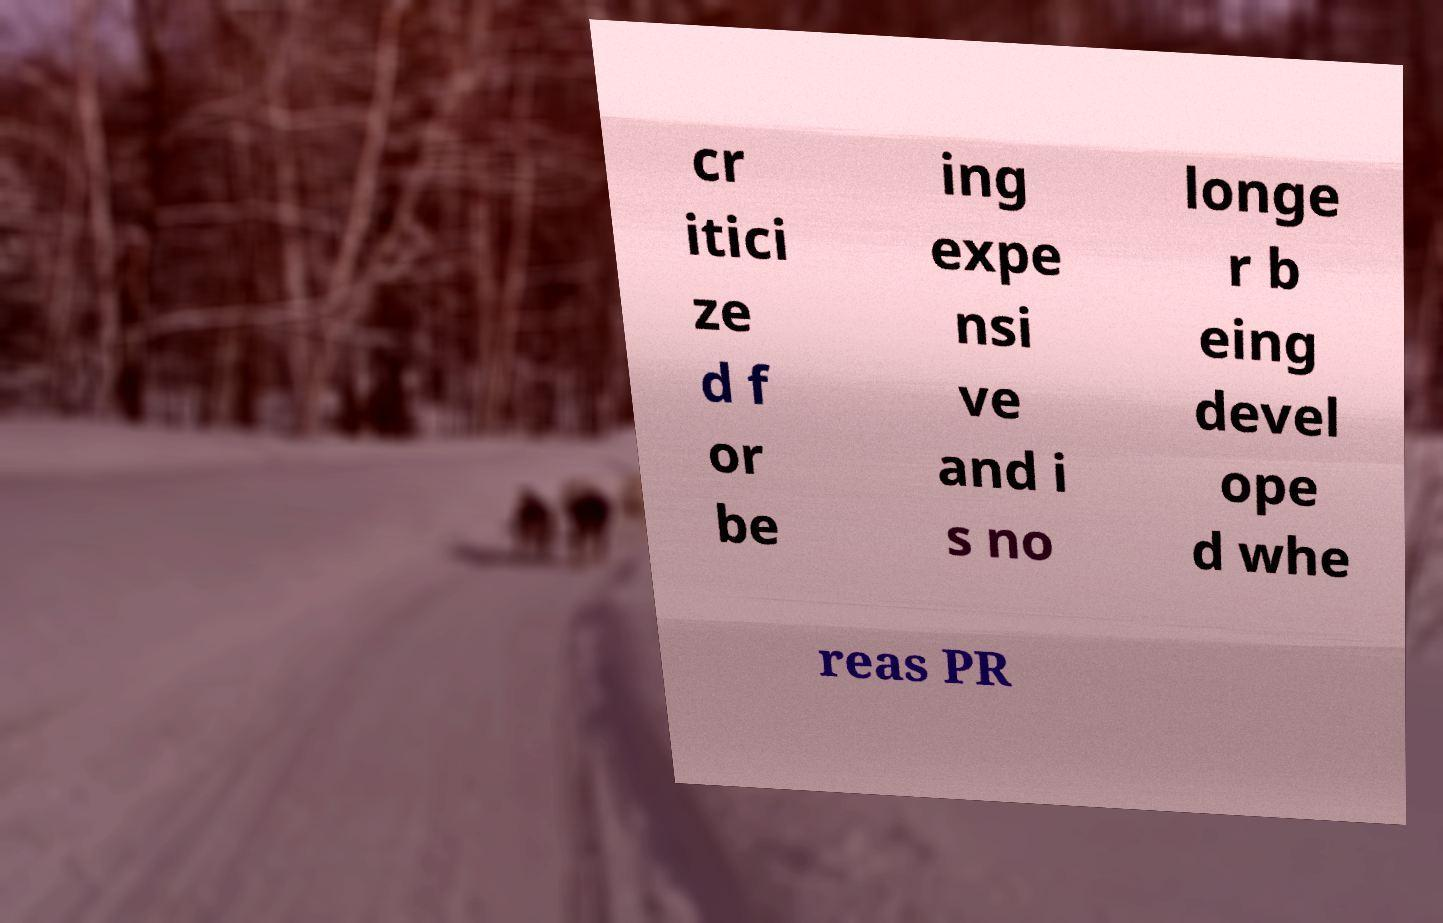Can you read and provide the text displayed in the image?This photo seems to have some interesting text. Can you extract and type it out for me? cr itici ze d f or be ing expe nsi ve and i s no longe r b eing devel ope d whe reas PR 